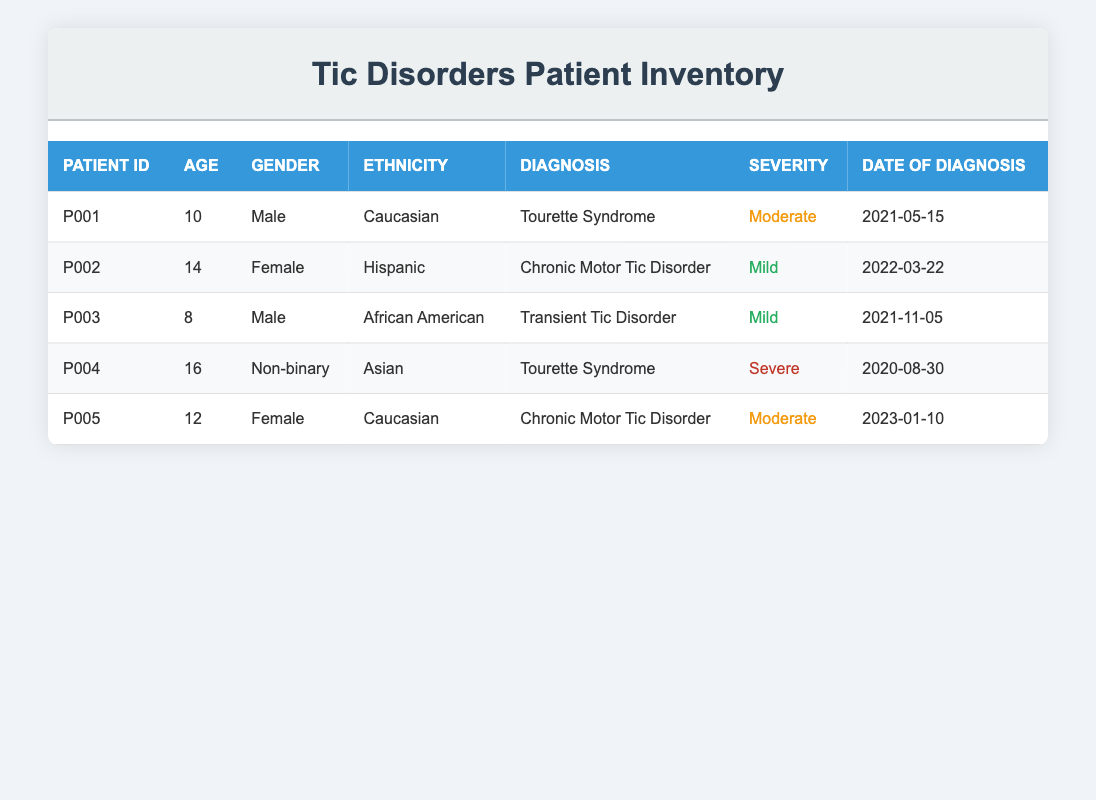What is the age of Patient P002? Patient P002 is listed in the table with an age of 14. The age is directly stated in the corresponding row for that patient.
Answer: 14 How many patients have been diagnosed with Tourette Syndrome? The table has two rows with the diagnosis of Tourette Syndrome (Patient P001 and P004). Counting these gives a total of 2.
Answer: 2 What is the severity level of Patient P004? In the row for Patient P004, the severity level is designated as 'Severe'. This information is clearly stated in the table.
Answer: Severe Which gender has a greater representation among the patients? There are 2 female patients (P002 and P005), 2 male patients (P001 and P003), and 1 non-binary patient (P004). Since both genders are represented equally by 2 patients each, the representation is equal, even considering the non-binary patient.
Answer: Equal representation What is the average age of patients with Severe tic disorder? The table shows only one patient with Severe tic disorder (Patient P004), who is 16 years old. The average age is essentially the age of this one patient, which is 16.
Answer: 16 Is there a Hispanic patient among the group? Looking at the table, we see that Patient P002 identifies as Hispanic. Therefore, the answer is yes based on the demographic information provided.
Answer: Yes How many patients were diagnosed in 2021? Patients P001 (May 15) and P003 (November 5) were diagnosed in 2021. Counting these patients totals to 2 diagnosed that year.
Answer: 2 Which diagnosis has the highest number of patients? The diagnoses listed are Tourette Syndrome, Chronic Motor Tic Disorder, and Transient Tic Disorder. Counting reveals that Chronic Motor Tic Disorder occurs twice (P002 and P005), while the others occur once each, making Chronic Motor Tic Disorder the most common.
Answer: Chronic Motor Tic Disorder What is the difference in age between the youngest and oldest patients? The youngest patient is P003, aged 8, and the oldest patient is P004, aged 16. The difference is calculated as 16 - 8 = 8 years.
Answer: 8 years 